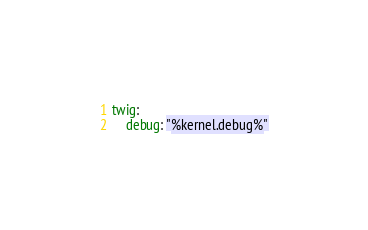Convert code to text. <code><loc_0><loc_0><loc_500><loc_500><_YAML_>twig:
    debug: "%kernel.debug%"</code> 